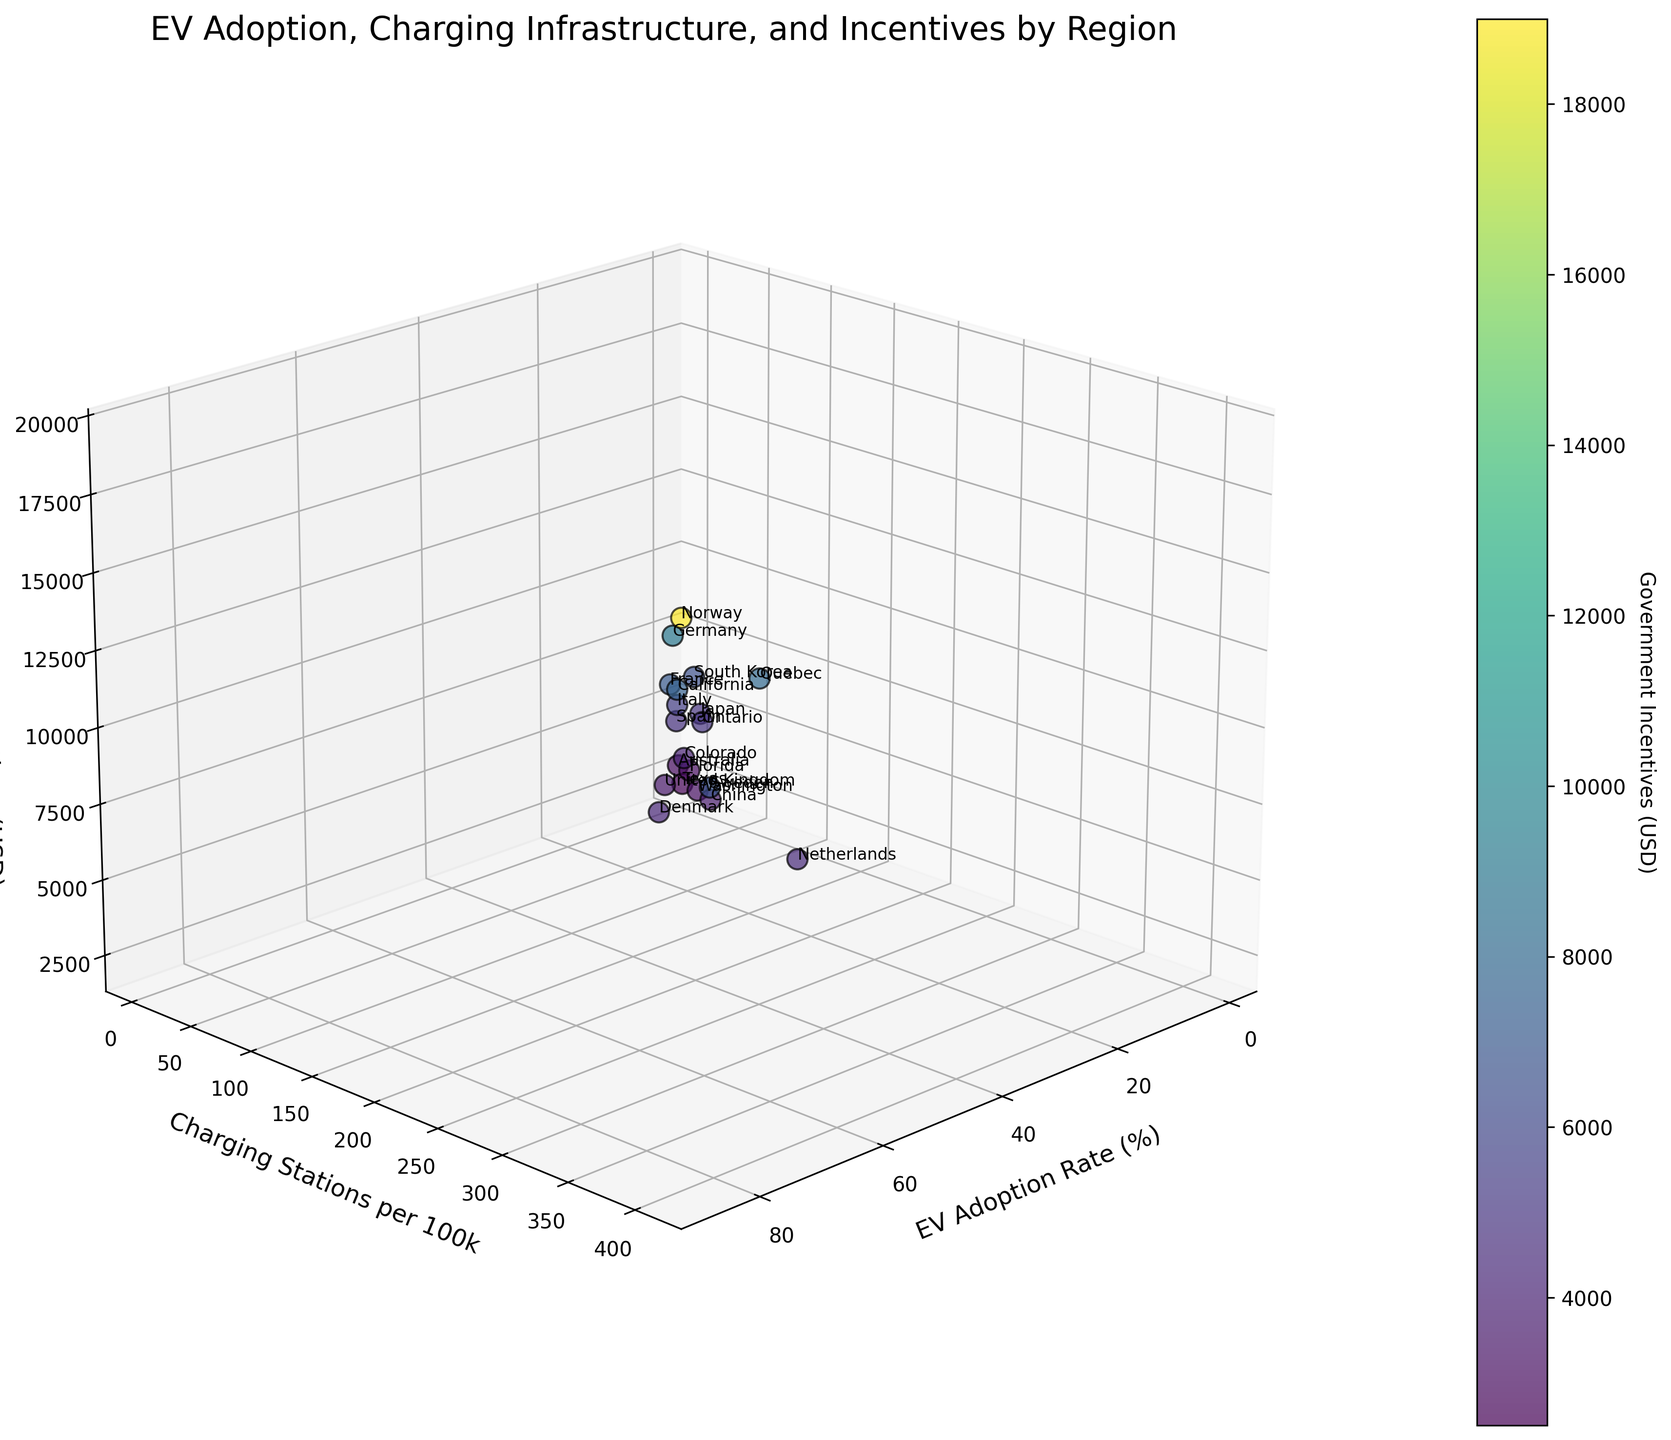What is the title of the figure? The title of the figure is usually displayed at the top of the plot and provides a brief description of what the chart represents. In this case, the title is "EV Adoption, Charging Infrastructure, and Incentives by Region."
Answer: EV Adoption, Charging Infrastructure, and Incentives by Region How many regions are represented in the plot? To find the number of regions, count the number of distinct data points or labels in the plot. There should be one for each region listed in the dataset. There are 19 regions shown in the figure.
Answer: 19 Which region has the highest EV adoption rate? For the highest EV adoption rate, locate the point farthest along the EV Adoption Rate axis. The corresponding label indicates which region it is. Norway has the highest EV adoption rate.
Answer: Norway What is the government incentive offered by California? Find the label for California in the plot and read the associated value on the Government Incentives axis. California offers USD 7500 as government incentives.
Answer: USD 7500 Compare the number of charging stations per 100k in Norway and Sweden; which has more? Locate the points for Norway and Sweden and compare their positions on the Charging Stations per 100k axis. Norway has more charging stations per 100k than Sweden.
Answer: Norway What is the relationship between EV adoption rates and government incentives? Look at the general trend along the EV Adoption Rate and Government Incentives axes. Determine if higher EV adoption rates correspond with higher government incentives. Generally, regions with higher EV adoption rates tend to have higher government incentives.
Answer: Higher incentives generally lead to higher adoption rates Which region has the least EV adoption rate and what are its government incentives? Find the point furthest along the lower end of the EV Adoption Rate axis and check the connected region label and its Government Incentives value. Japan has the least EV adoption rate at 1.2%, with government incentives of USD 5000.
Answer: Japan, USD 5000 Which regions have government incentives less than USD 5000? Identify the points positioned below USD 5000 on the Government Incentives axis and list their corresponding labels. The regions are China, Netherlands, United Kingdom, Denmark, Florida, Spain, Washington, and Australia.
Answer: China, Netherlands, United Kingdom, Denmark, Florida, Spain, Washington, Australia Is there a region with a higher EV adoption rate than Germany but lower than Sweden? Identify the positions on the EV Adoption Rate axis and find a point between Germany and Sweden. Netherlands fits this criterion with an EV adoption rate of 24.7%.
Answer: Netherlands Does Quebec have more charging stations per 100k compared to Germany? Locate Quebec's and Germany's points on the Charging Stations per 100k axis to compare their values. Quebec has more charging stations per 100k than Germany (110 vs 58).
Answer: Yes 